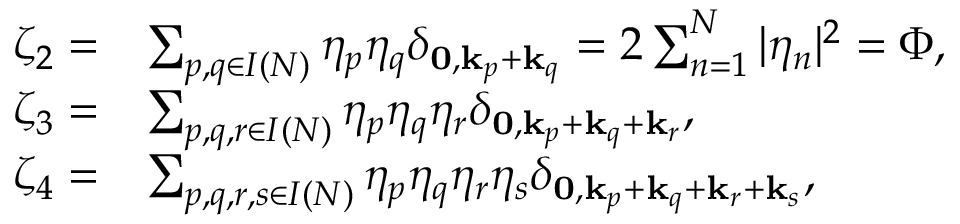Convert formula to latex. <formula><loc_0><loc_0><loc_500><loc_500>\begin{array} { r l } { \zeta _ { 2 } = } & { \sum _ { p , q \in I ( N ) } \eta _ { p } \eta _ { q } \delta _ { 0 , k _ { p } + k _ { q } } = 2 \sum _ { n = 1 } ^ { N } | \eta _ { n } | ^ { 2 } = \Phi , } \\ { \zeta _ { 3 } = } & { \sum _ { p , q , r \in { I } ( N ) } \eta _ { p } \eta _ { q } \eta _ { r } \delta _ { 0 , k _ { p } + k _ { q } + { k _ { r } } } , } \\ { \zeta _ { 4 } = } & { \sum _ { p , q , r , s \in { I } ( N ) } \eta _ { p } \eta _ { q } \eta _ { r } \eta _ { s } \delta _ { 0 , k _ { p } + k _ { q } + { k _ { r } } + k _ { s } } , } \end{array}</formula> 